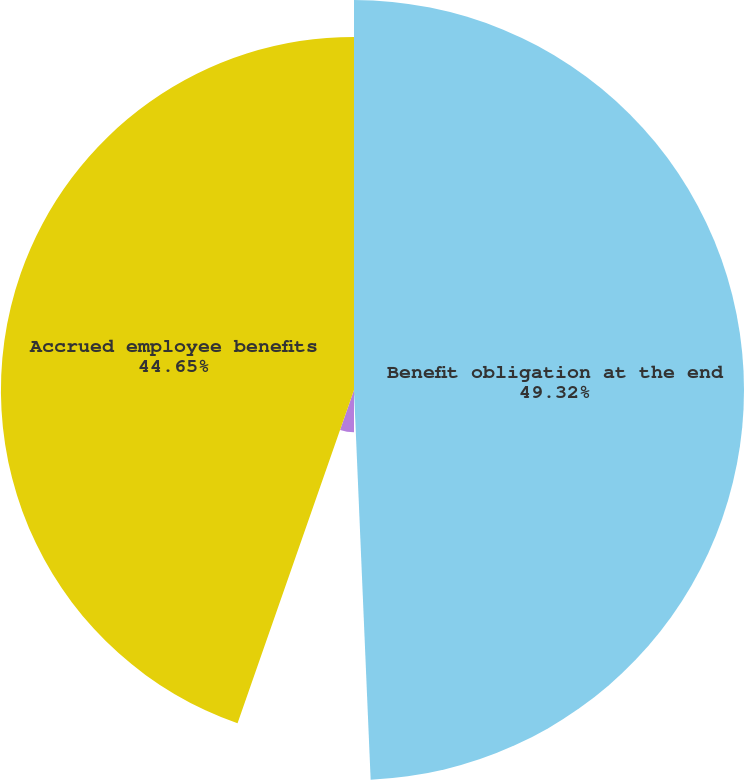Convert chart. <chart><loc_0><loc_0><loc_500><loc_500><pie_chart><fcel>Benefit obligation at the end<fcel>Benefits paid<fcel>Other current liabilities<fcel>Accrued employee benefits<nl><fcel>49.32%<fcel>0.68%<fcel>5.35%<fcel>44.65%<nl></chart> 